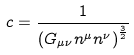Convert formula to latex. <formula><loc_0><loc_0><loc_500><loc_500>c = \frac { 1 } { \left ( G _ { \mu \nu } n ^ { \mu } n ^ { \nu } \right ) ^ { \frac { 3 } { 2 } } }</formula> 